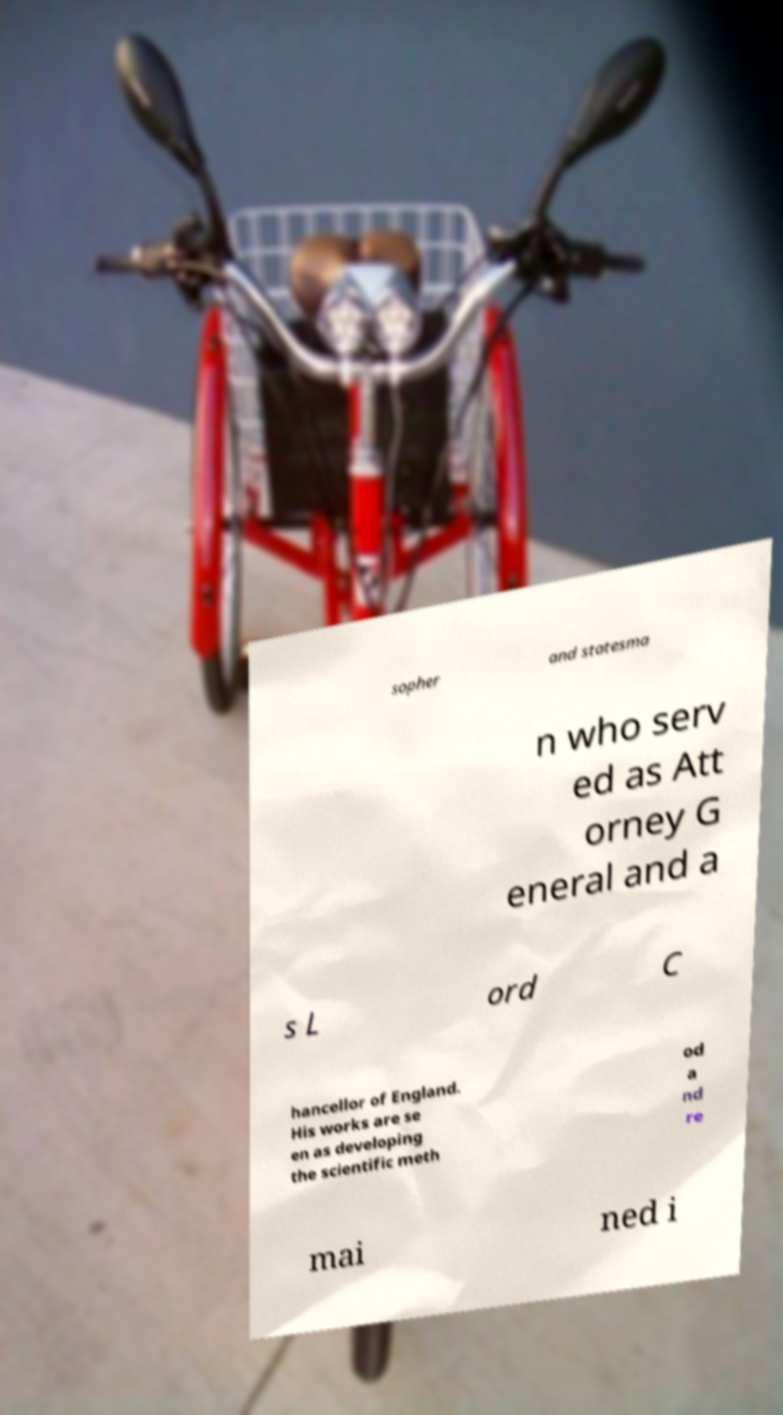Can you accurately transcribe the text from the provided image for me? sopher and statesma n who serv ed as Att orney G eneral and a s L ord C hancellor of England. His works are se en as developing the scientific meth od a nd re mai ned i 